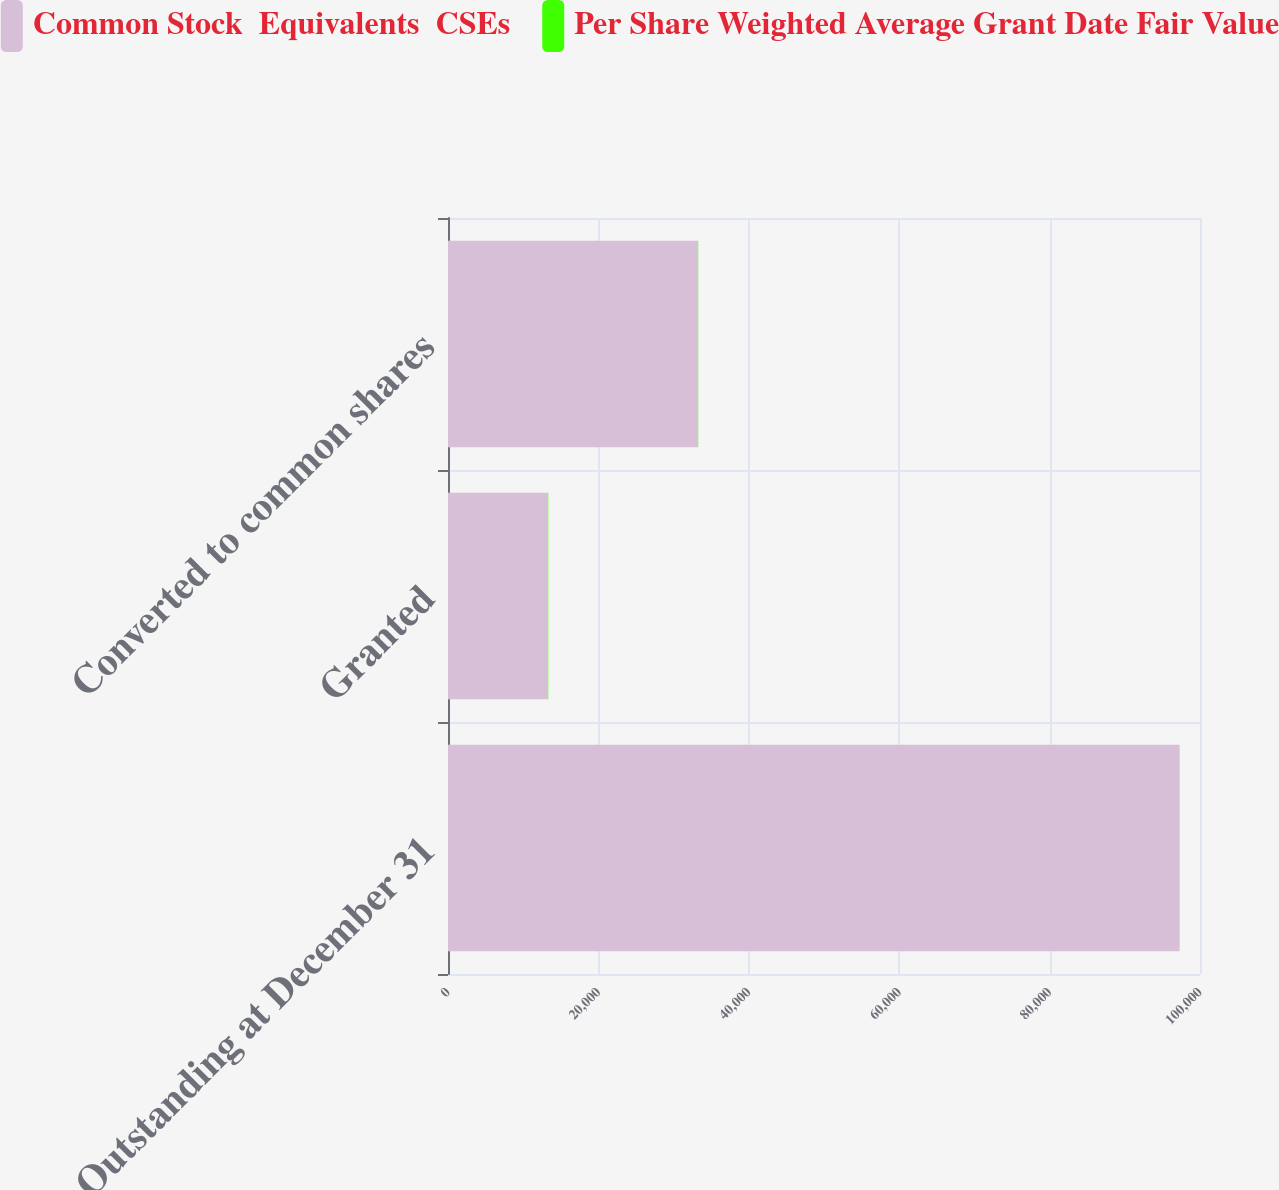Convert chart. <chart><loc_0><loc_0><loc_500><loc_500><stacked_bar_chart><ecel><fcel>Outstanding at December 31<fcel>Granted<fcel>Converted to common shares<nl><fcel>Common Stock  Equivalents  CSEs<fcel>97268<fcel>13294<fcel>33234<nl><fcel>Per Share Weighted Average Grant Date Fair Value<fcel>17.79<fcel>37.24<fcel>36.15<nl></chart> 